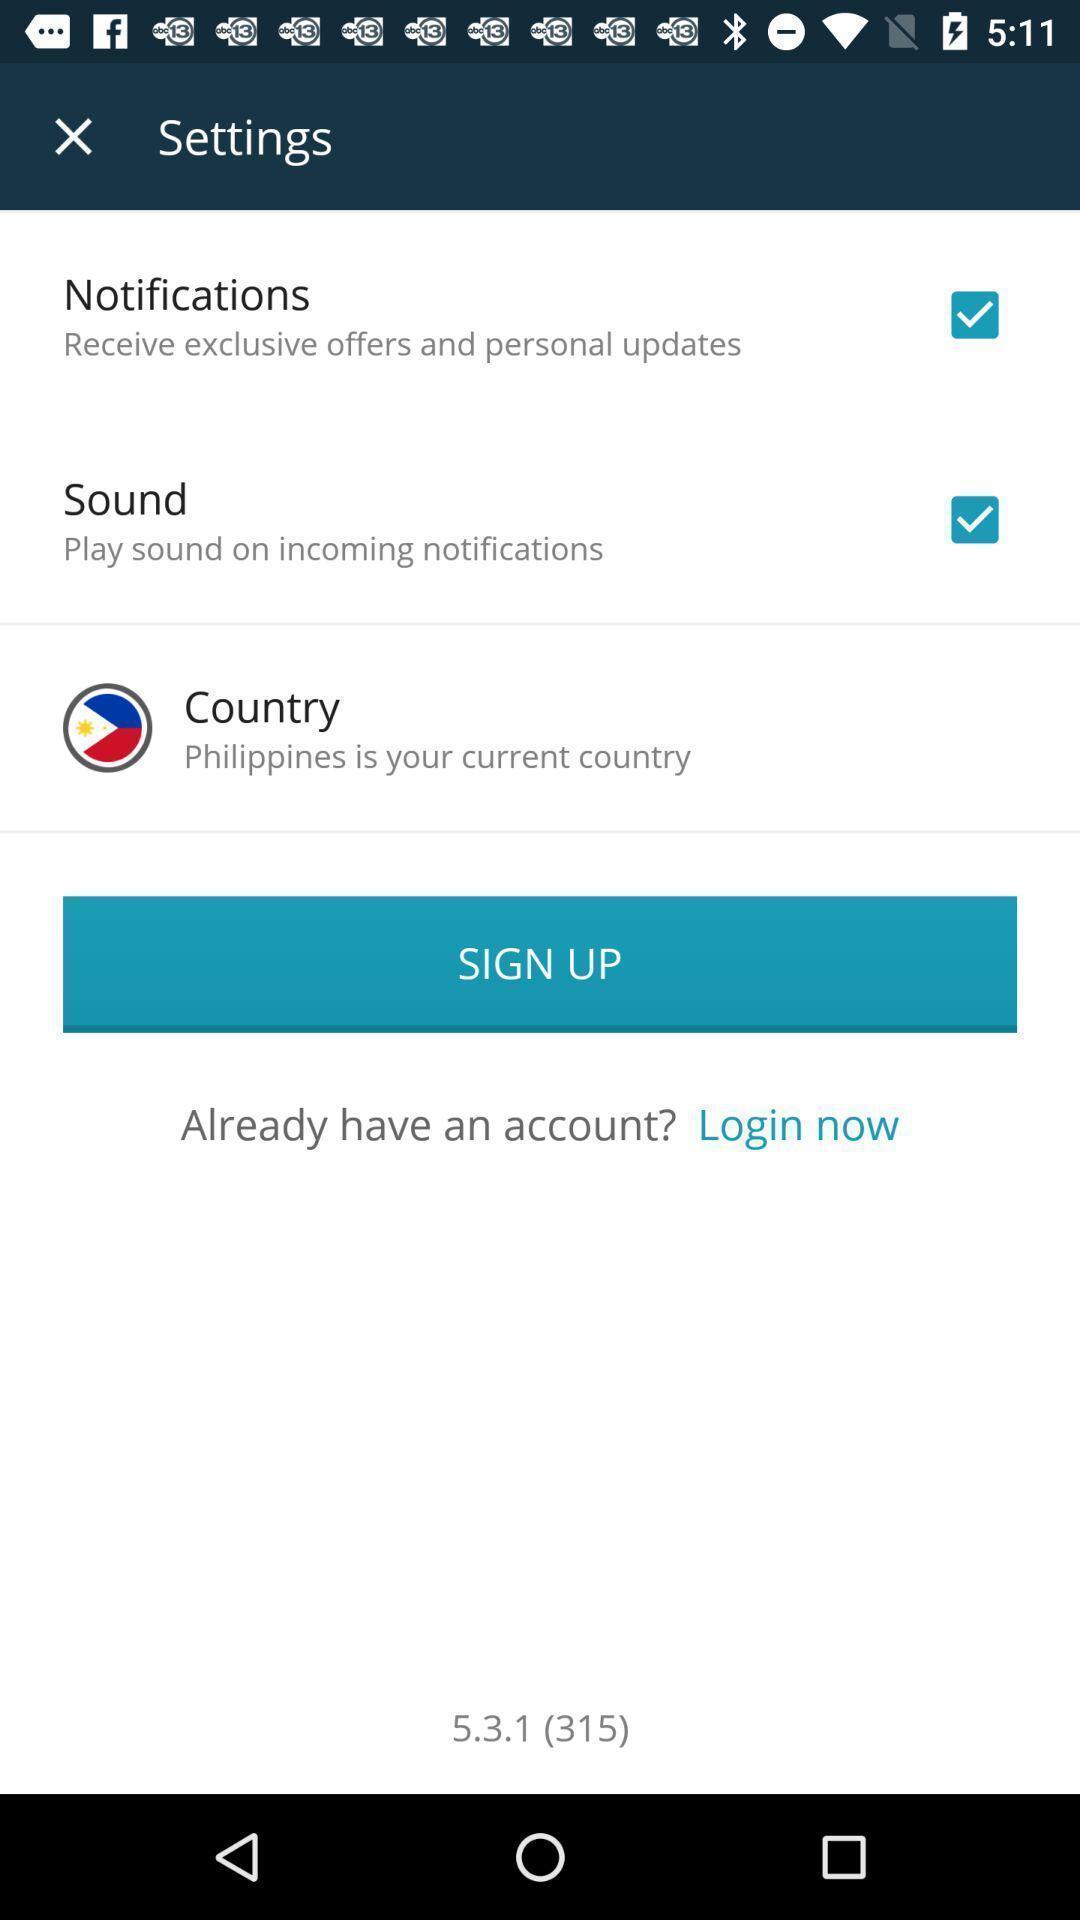What can you discern from this picture? Sign up page to get the access form the app. 